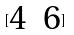Convert formula to latex. <formula><loc_0><loc_0><loc_500><loc_500>[ \begin{matrix} 4 & 6 \end{matrix} ]</formula> 